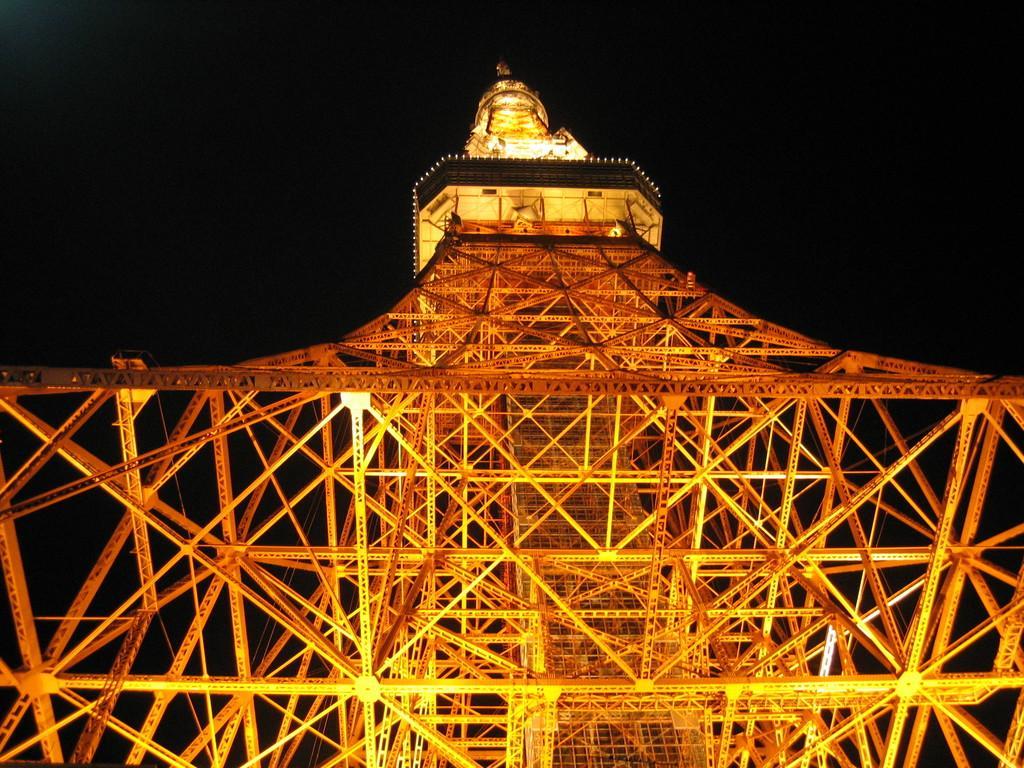In one or two sentences, can you explain what this image depicts? In the center of the image there is an eiffel tower. In the background we can see sky. 